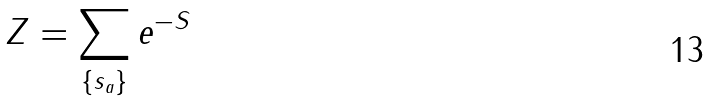Convert formula to latex. <formula><loc_0><loc_0><loc_500><loc_500>Z = \sum _ { \{ s _ { a } \} } e ^ { - S }</formula> 